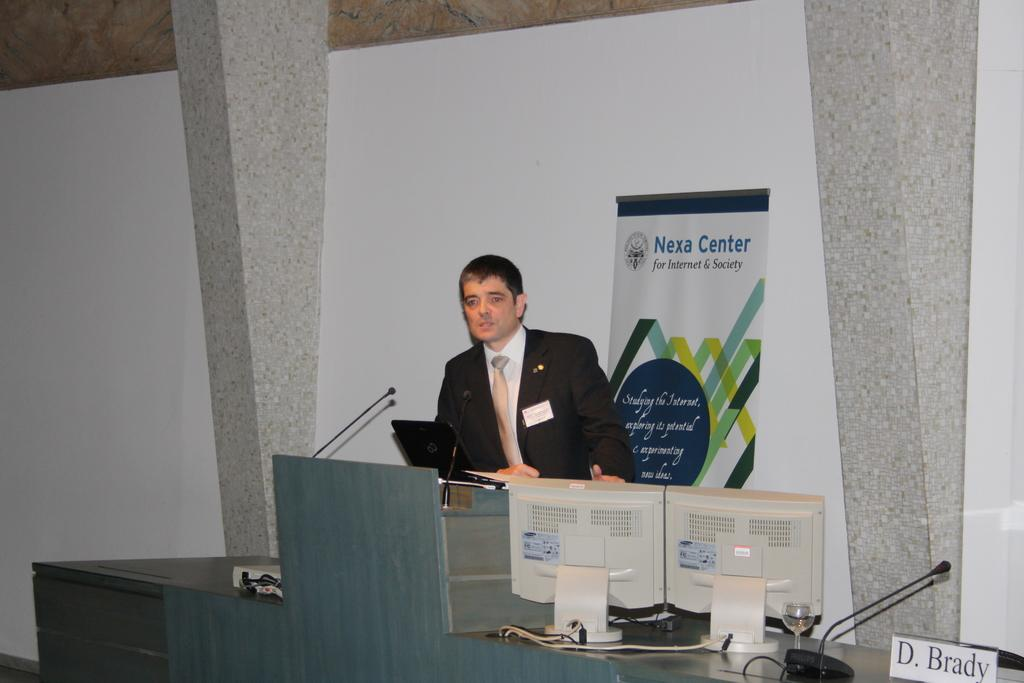Who is the main subject in the image? There is a man in the image. What is the man doing in the image? The man is speaking at a podium. What objects are in front of the man? There are two microphones and a laptop in front of the man. How many trucks are parked behind the man in the image? There are no trucks visible in the image. Is there a cushion on the podium where the man is speaking? The image does not show a cushion on the podium. 